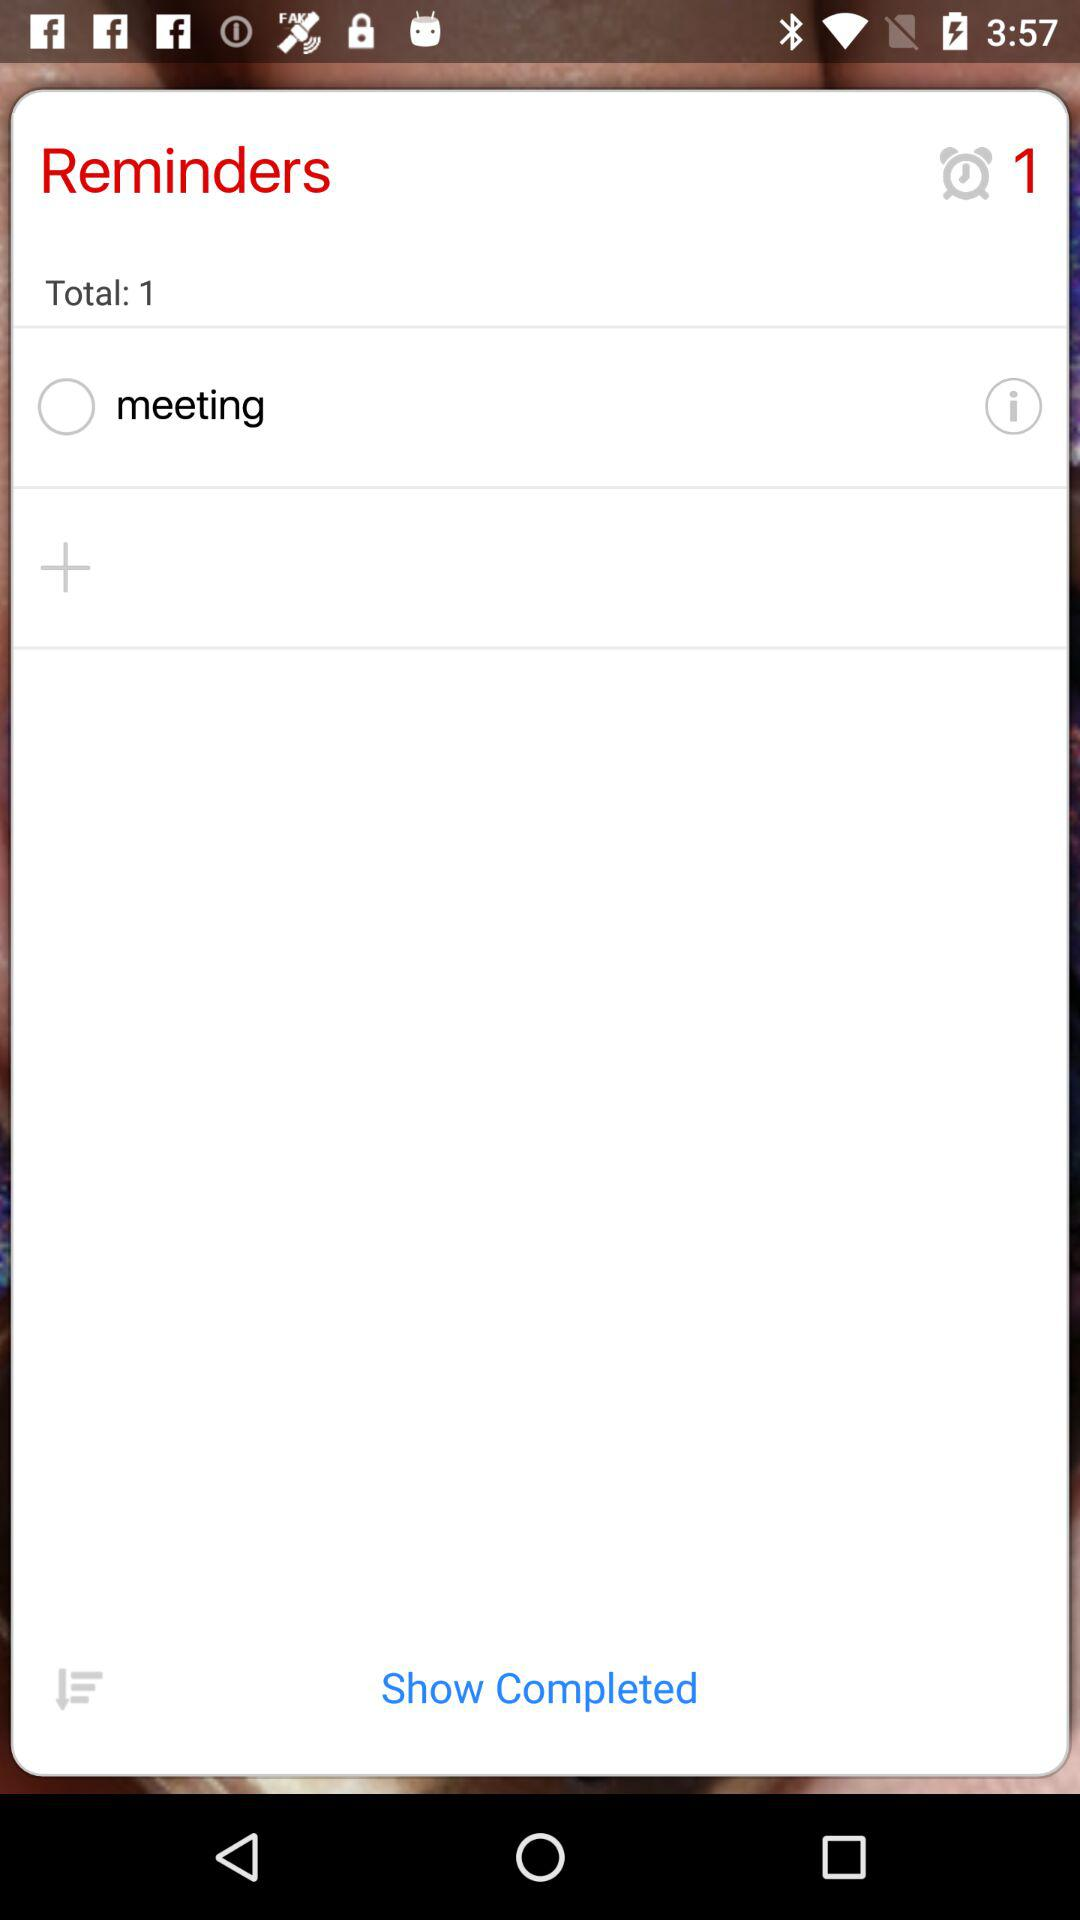How many reminders are there?
Answer the question using a single word or phrase. 1 